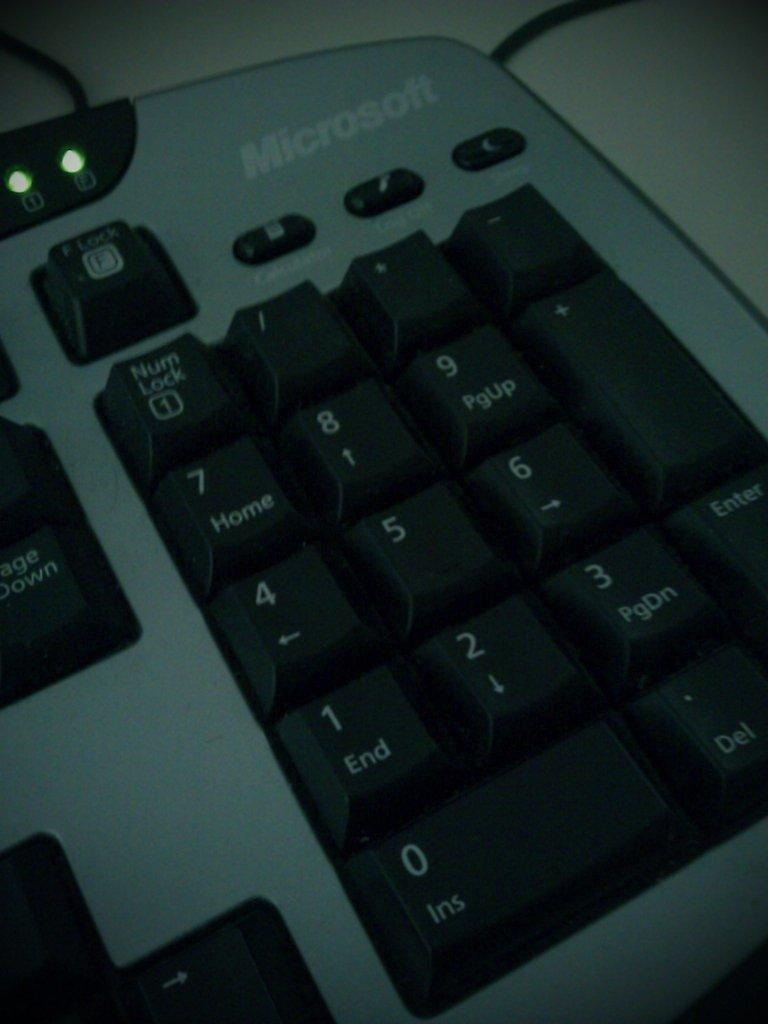Provide a one-sentence caption for the provided image. A close up of the numbers on a microsoft keyboard. 